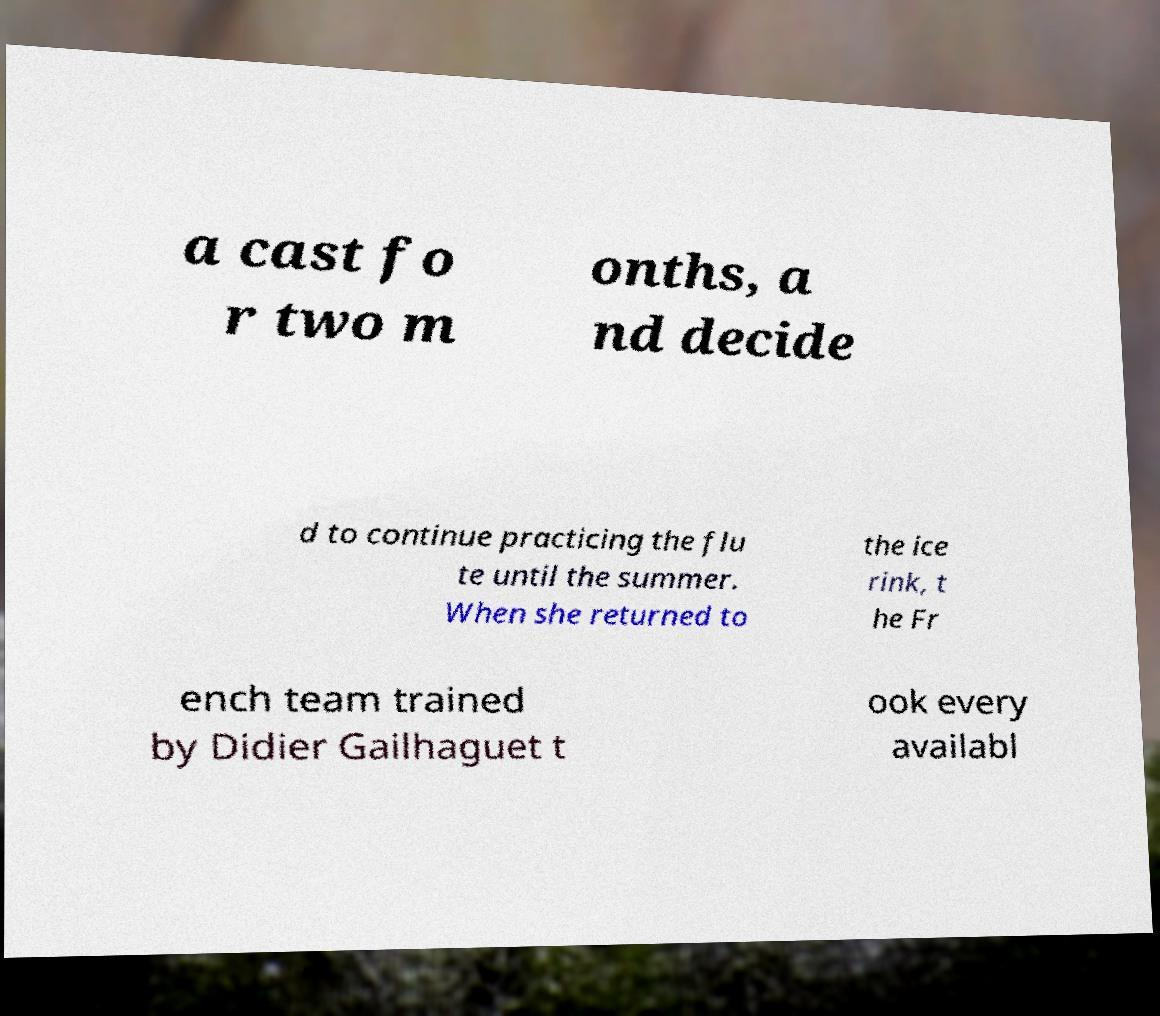Could you extract and type out the text from this image? a cast fo r two m onths, a nd decide d to continue practicing the flu te until the summer. When she returned to the ice rink, t he Fr ench team trained by Didier Gailhaguet t ook every availabl 